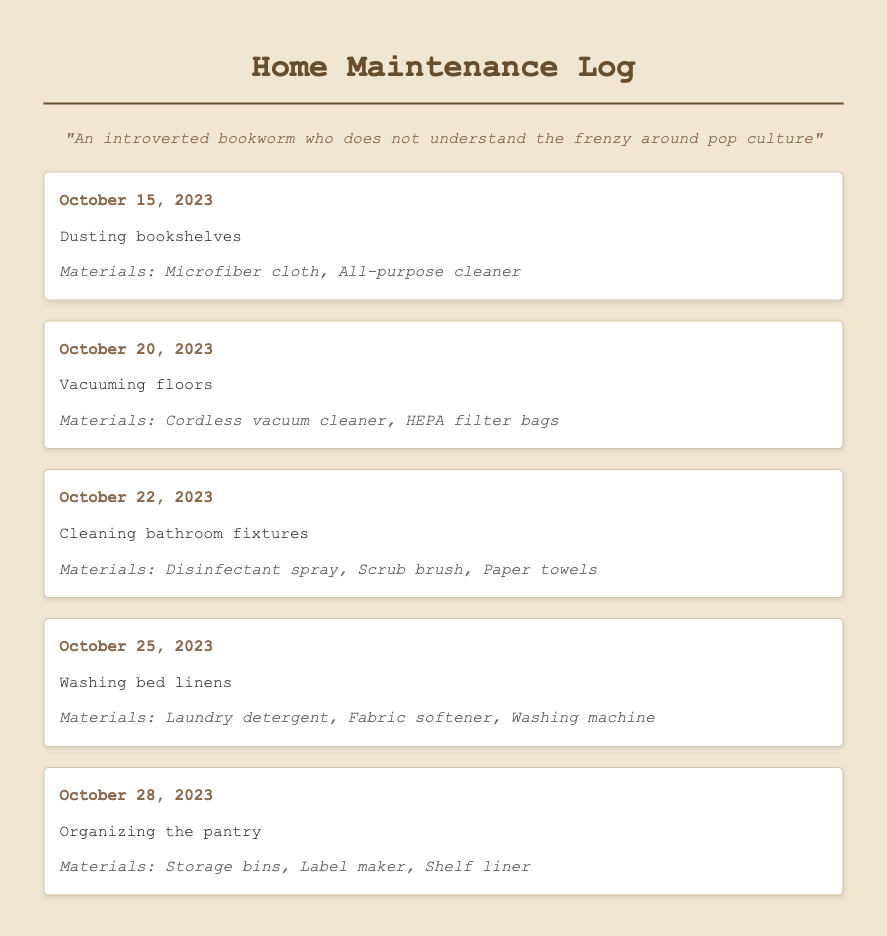What task was performed on October 15, 2023? The task performed on this date was dusting bookshelves.
Answer: Dusting bookshelves What materials were used on October 22, 2023? The materials used for cleaning bathroom fixtures included disinfectant spray, scrub brush, and paper towels.
Answer: Disinfectant spray, scrub brush, paper towels How many tasks were recorded in the log? There are five tasks listed in the maintenance log.
Answer: Five Which date corresponds to washing bed linens? The date for washing bed linens is October 25, 2023.
Answer: October 25, 2023 What cleaning task involves a vacuum? The task that involves a vacuum is vacuuming floors.
Answer: Vacuuming floors What is the last task documented? The last task recorded in the log is organizing the pantry.
Answer: Organizing the pantry What is the purpose of the label maker in the log? The label maker was used for organizing the pantry.
Answer: Organizing the pantry Which cleaning task used a microfiber cloth? Dusting bookshelves used a microfiber cloth.
Answer: Dusting bookshelves 